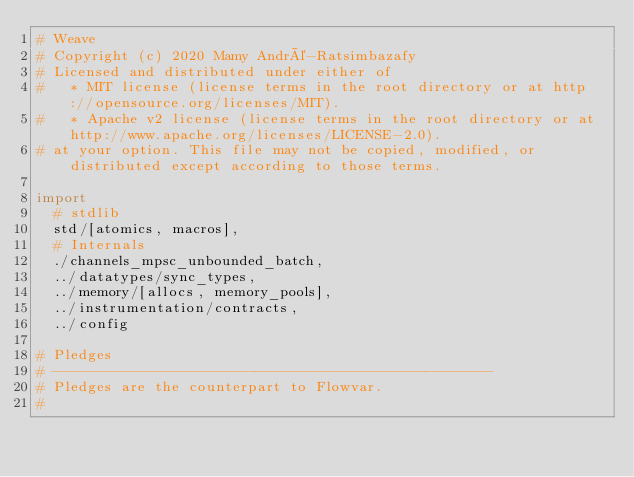Convert code to text. <code><loc_0><loc_0><loc_500><loc_500><_Nim_># Weave
# Copyright (c) 2020 Mamy André-Ratsimbazafy
# Licensed and distributed under either of
#   * MIT license (license terms in the root directory or at http://opensource.org/licenses/MIT).
#   * Apache v2 license (license terms in the root directory or at http://www.apache.org/licenses/LICENSE-2.0).
# at your option. This file may not be copied, modified, or distributed except according to those terms.

import
  # stdlib
  std/[atomics, macros],
  # Internals
  ./channels_mpsc_unbounded_batch,
  ../datatypes/sync_types,
  ../memory/[allocs, memory_pools],
  ../instrumentation/contracts,
  ../config

# Pledges
# ----------------------------------------------------
# Pledges are the counterpart to Flowvar.
#</code> 